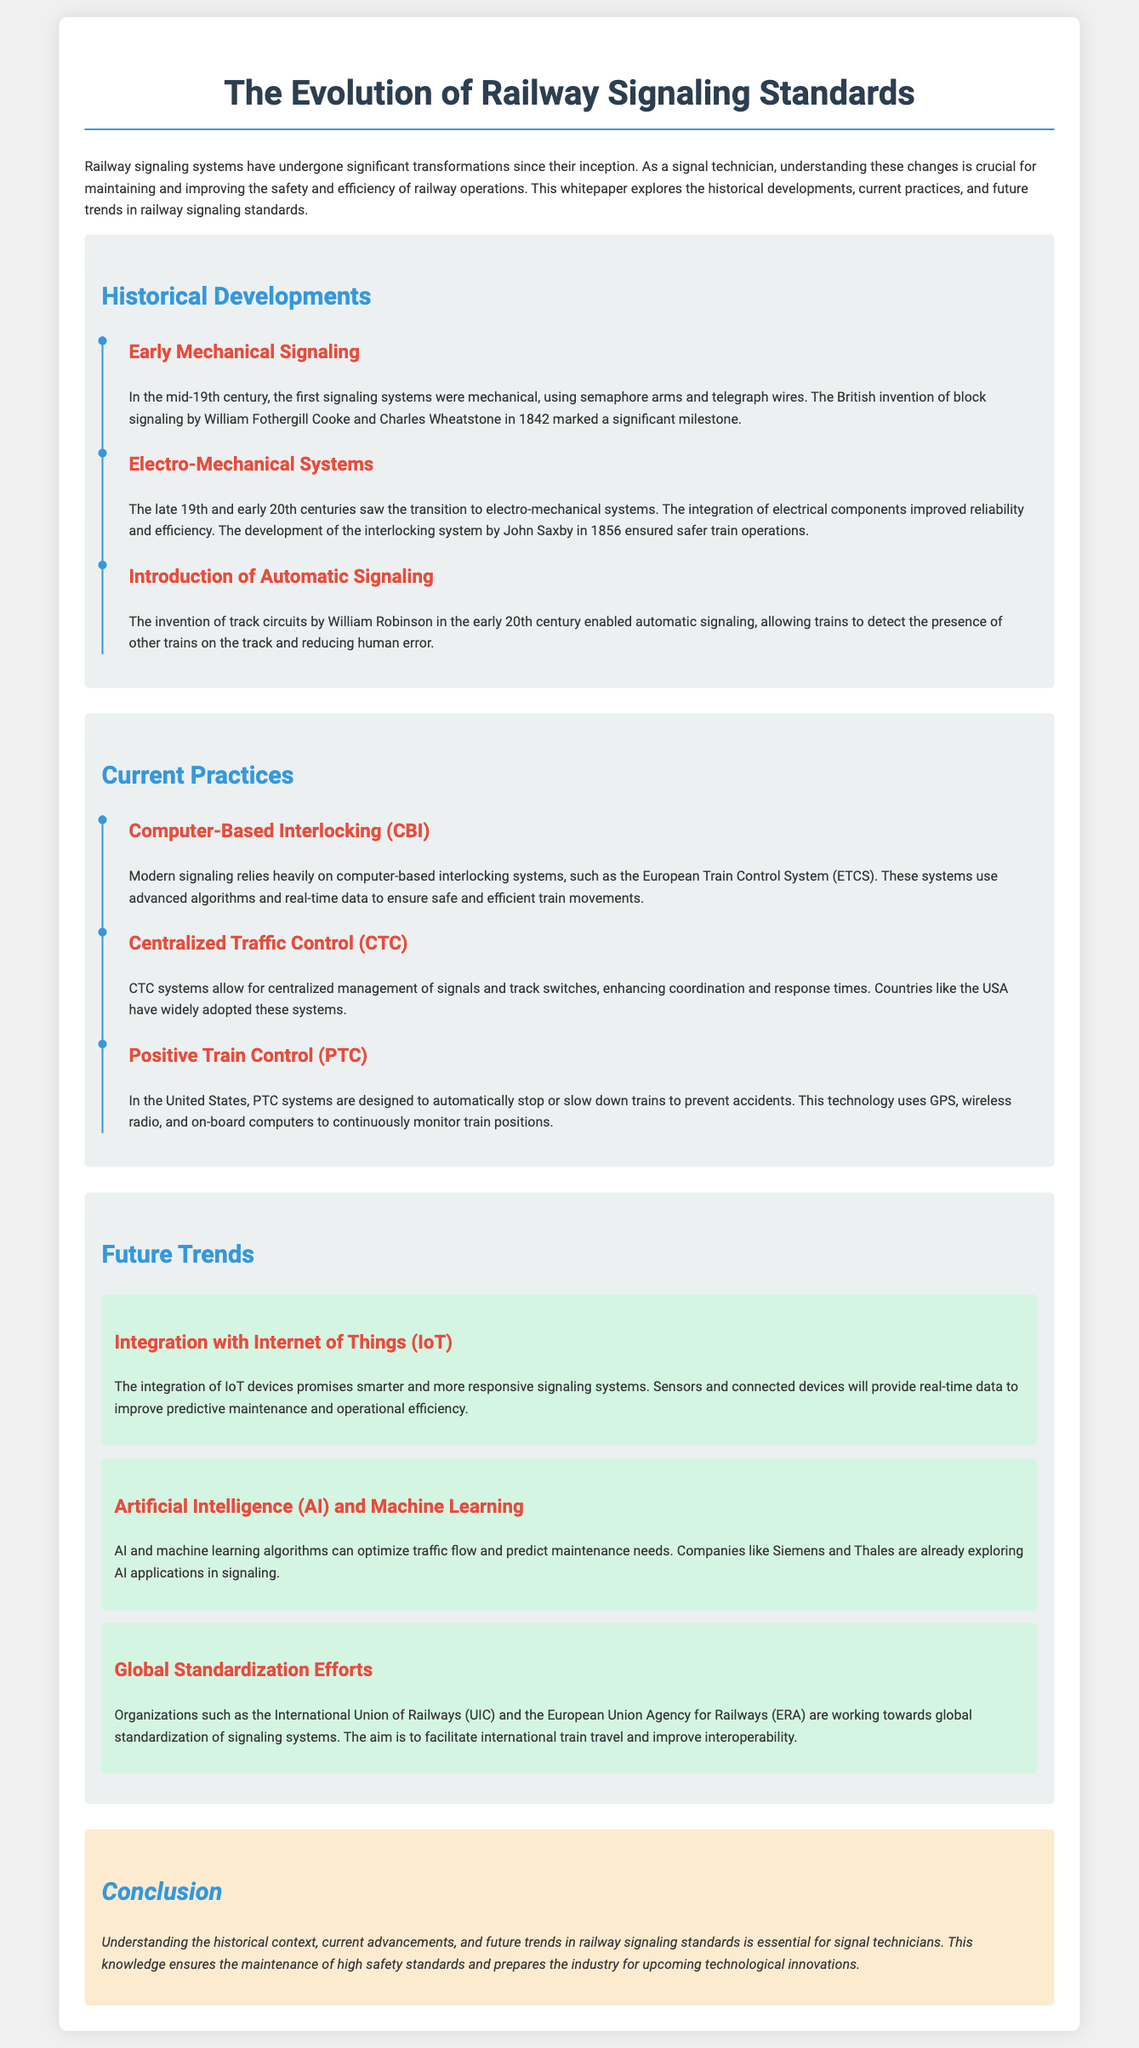What year was the invention of block signaling? The document states that block signaling was invented in 1842.
Answer: 1842 Who developed the interlocking system? The timeline mentions John Saxby as the developer of the interlocking system in 1856.
Answer: John Saxby What is a current practice in railway signaling mentioned? The document lists Computer-Based Interlocking as a current practice in modern signaling.
Answer: Computer-Based Interlocking What does PTC stand for? According to the document, PTC stands for Positive Train Control.
Answer: Positive Train Control Which organization is mentioned as working on global standardization of signaling systems? The document refers to the International Union of Railways as one organization involved in this effort.
Answer: International Union of Railways What technology promises smarter signaling systems in the future? The document highlights the integration of Internet of Things devices as a future trend.
Answer: Internet of Things Which company is exploring AI applications in signaling? The document mentions Siemens as one of the companies involved in exploring AI applications.
Answer: Siemens What was a significant milestone in early mechanical signaling? The document identifies the British invention of block signaling as a major milestone.
Answer: block signaling 